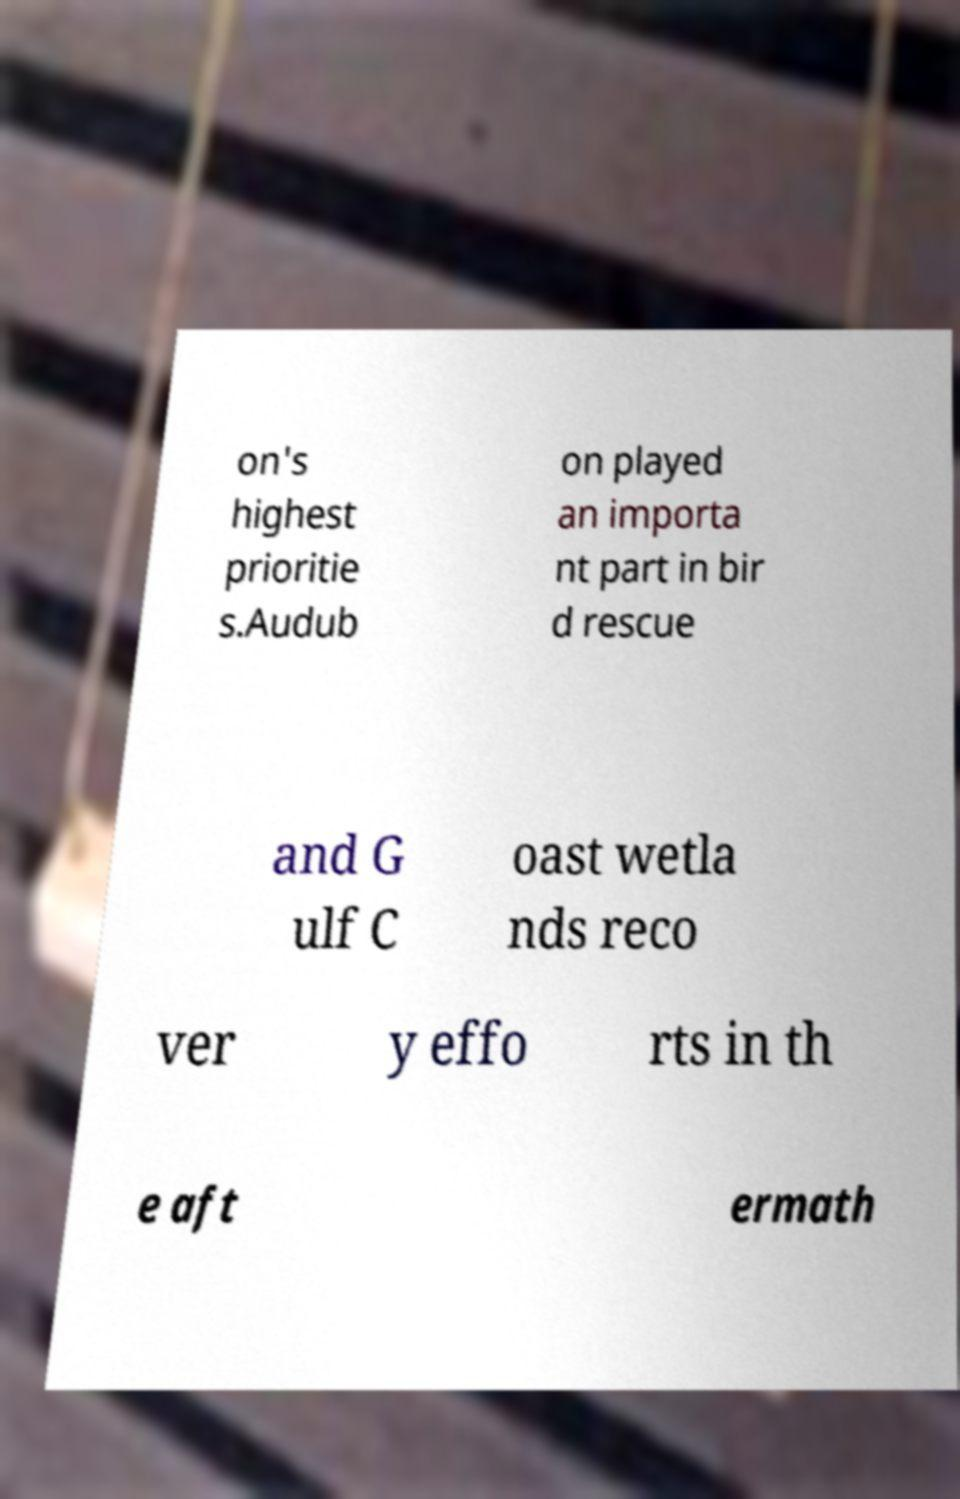Could you extract and type out the text from this image? on's highest prioritie s.Audub on played an importa nt part in bir d rescue and G ulf C oast wetla nds reco ver y effo rts in th e aft ermath 